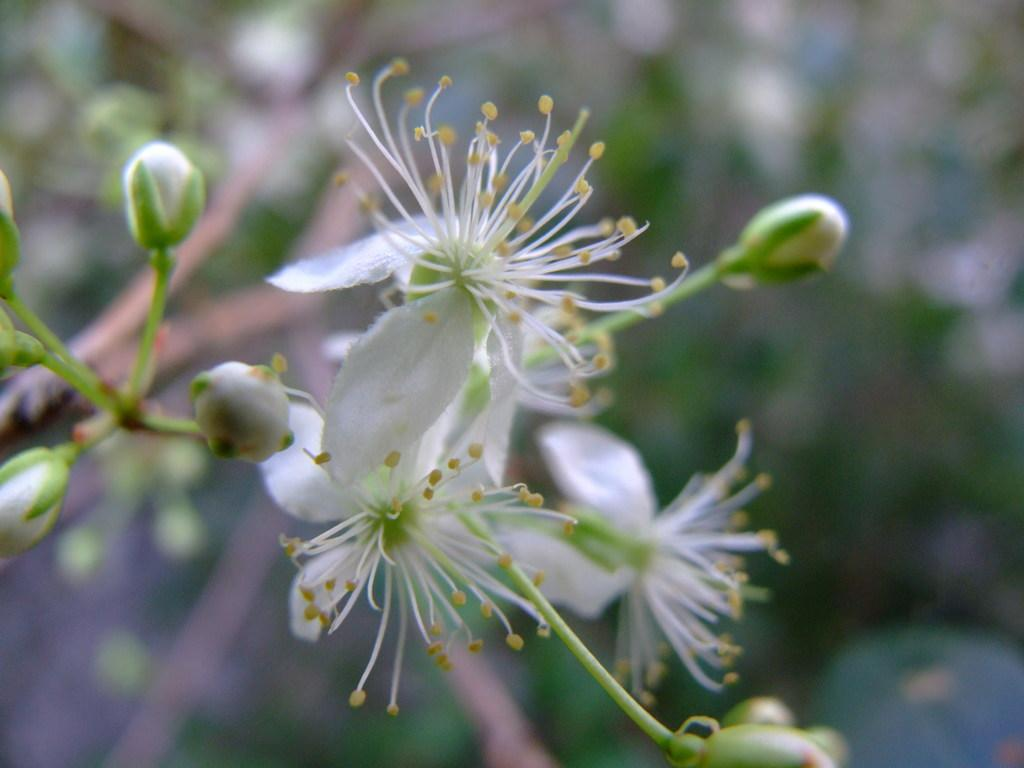What type of plants can be seen in the image? There are flowers in the image. Are there any unopened flowers in the image? Yes, there are flower buds in the image. Can you describe the background of the image? The background of the image is blurry. What type of profit can be seen in the image? There is no mention of profit in the image, as it features flowers and flower buds. Can you identify any circles in the image? There is no mention of circles in the image, as it focuses on flowers and flower buds. 